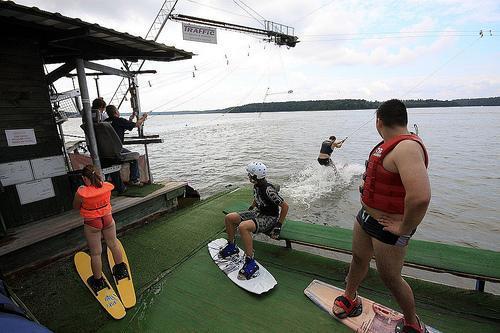How many people are visible?
Give a very brief answer. 6. 